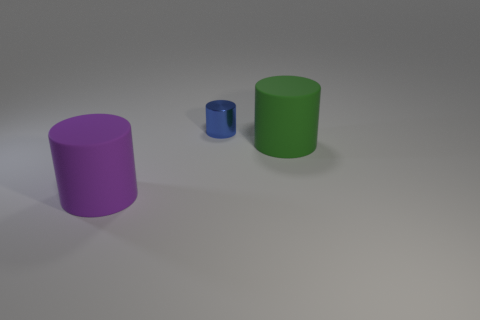Add 3 tiny blue objects. How many objects exist? 6 Add 3 tiny blue shiny cylinders. How many tiny blue shiny cylinders are left? 4 Add 1 small gray blocks. How many small gray blocks exist? 1 Subtract all purple cylinders. How many cylinders are left? 2 Subtract all purple cylinders. How many cylinders are left? 2 Subtract 0 blue blocks. How many objects are left? 3 Subtract 2 cylinders. How many cylinders are left? 1 Subtract all brown cylinders. Subtract all brown cubes. How many cylinders are left? 3 Subtract all red cubes. How many purple cylinders are left? 1 Subtract all blue matte spheres. Subtract all large matte objects. How many objects are left? 1 